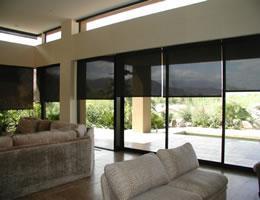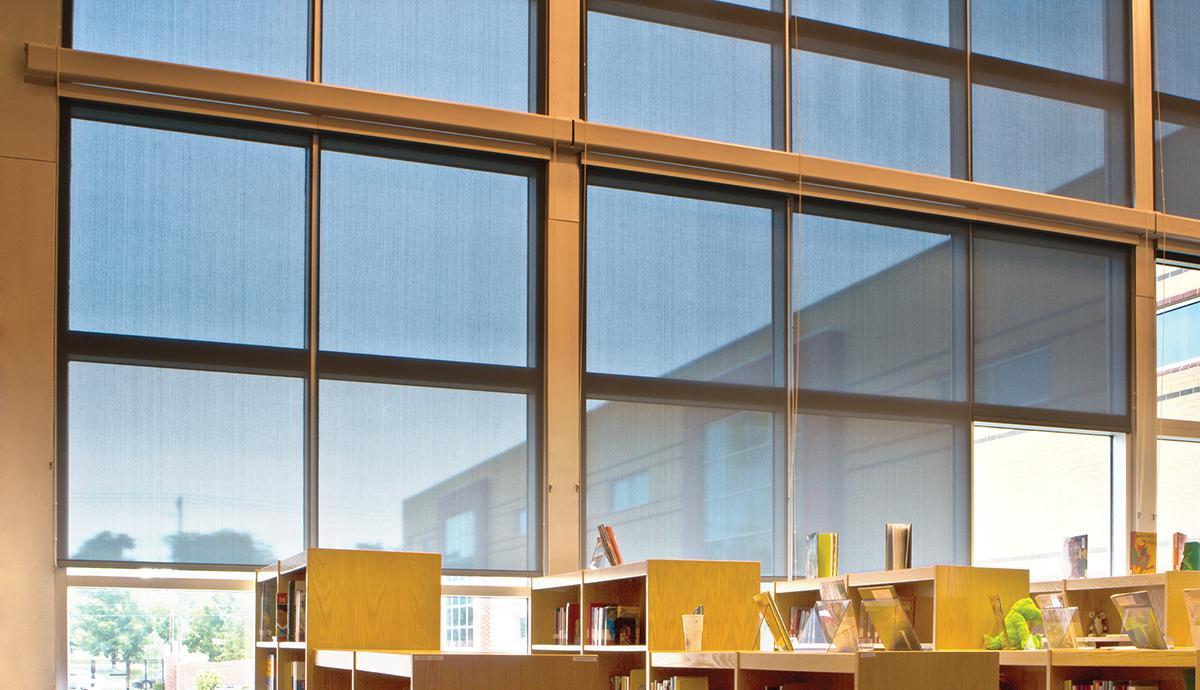The first image is the image on the left, the second image is the image on the right. Assess this claim about the two images: "One image contains computers at desks, like in an office, and the other does not.". Correct or not? Answer yes or no. No. The first image is the image on the left, the second image is the image on the right. Considering the images on both sides, is "An image shows an office space with a wall of square-paned window in front of work-stations." valid? Answer yes or no. Yes. 